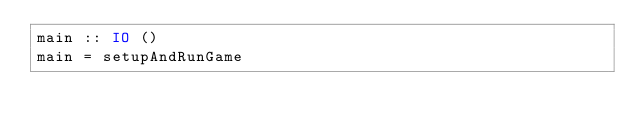<code> <loc_0><loc_0><loc_500><loc_500><_Haskell_>main :: IO ()
main = setupAndRunGame
</code> 